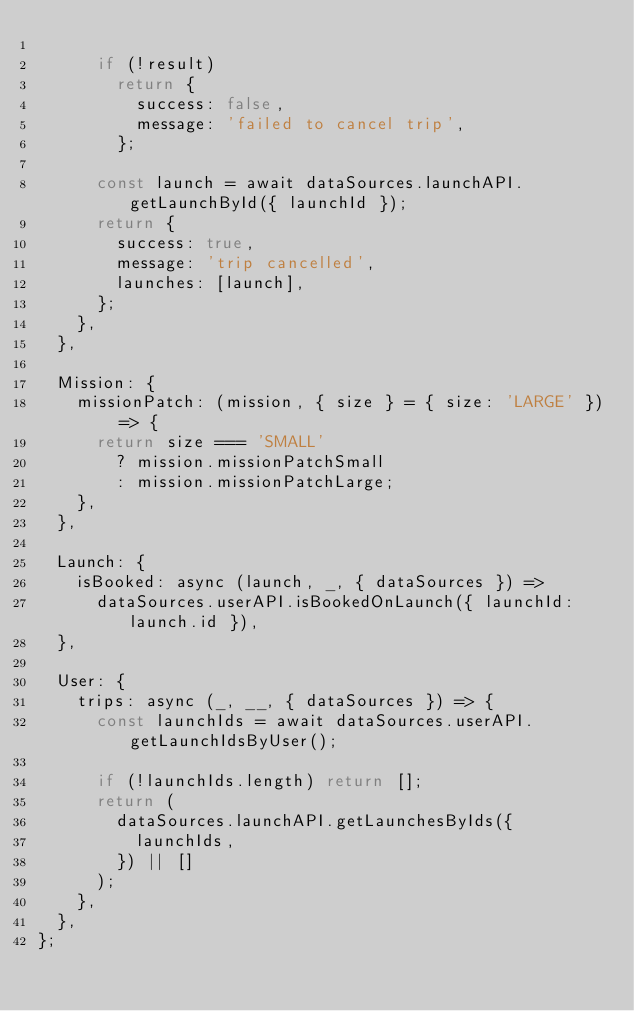Convert code to text. <code><loc_0><loc_0><loc_500><loc_500><_JavaScript_>      
      if (!result)
        return {
          success: false,
          message: 'failed to cancel trip',
        };
      
      const launch = await dataSources.launchAPI.getLaunchById({ launchId });
      return {
        success: true,
        message: 'trip cancelled',
        launches: [launch],
      };
    },
  },
  
  Mission: {
    missionPatch: (mission, { size } = { size: 'LARGE' }) => {
      return size === 'SMALL'
        ? mission.missionPatchSmall
        : mission.missionPatchLarge;
    },
  },
  
  Launch: {
    isBooked: async (launch, _, { dataSources }) =>
      dataSources.userAPI.isBookedOnLaunch({ launchId: launch.id }),
  },
  
  User: {
    trips: async (_, __, { dataSources }) => {
      const launchIds = await dataSources.userAPI.getLaunchIdsByUser();
      
      if (!launchIds.length) return [];
      return (
        dataSources.launchAPI.getLaunchesByIds({
          launchIds,
        }) || []
      );
    },
  },
};</code> 